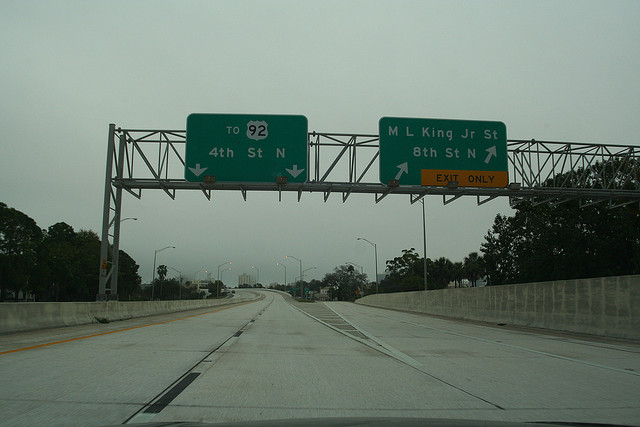Extract all visible text content from this image. 4th To 92 St N N St 8th ONLY EXIT St Jr King L M 